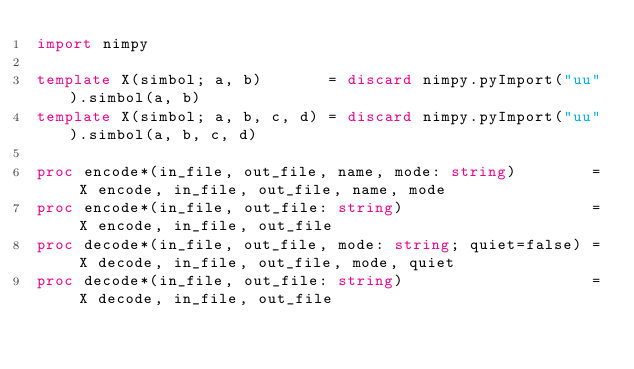<code> <loc_0><loc_0><loc_500><loc_500><_Nim_>import nimpy

template X(simbol; a, b)       = discard nimpy.pyImport("uu").simbol(a, b)
template X(simbol; a, b, c, d) = discard nimpy.pyImport("uu").simbol(a, b, c, d)

proc encode*(in_file, out_file, name, mode: string)        = X encode, in_file, out_file, name, mode
proc encode*(in_file, out_file: string)                    = X encode, in_file, out_file
proc decode*(in_file, out_file, mode: string; quiet=false) = X decode, in_file, out_file, mode, quiet
proc decode*(in_file, out_file: string)                    = X decode, in_file, out_file
</code> 